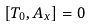Convert formula to latex. <formula><loc_0><loc_0><loc_500><loc_500>[ T _ { 0 } , A _ { x } ] = 0</formula> 